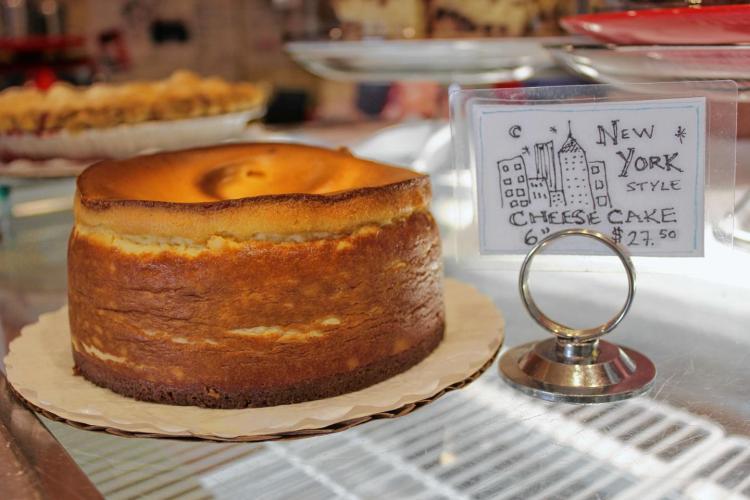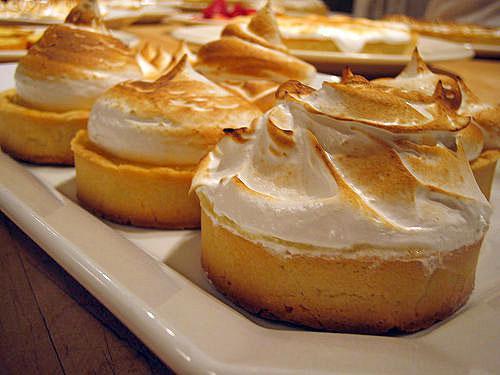The first image is the image on the left, the second image is the image on the right. Evaluate the accuracy of this statement regarding the images: "One image shows one dessert slice with white on its top, and the other image shows a dessert on a round plate consisting of round layers alternating with creamy layers.". Is it true? Answer yes or no. No. The first image is the image on the left, the second image is the image on the right. Considering the images on both sides, is "A cake with multiple layers is sitting on a plate in one image, while a single serving of a different dessert in the second image." valid? Answer yes or no. No. 